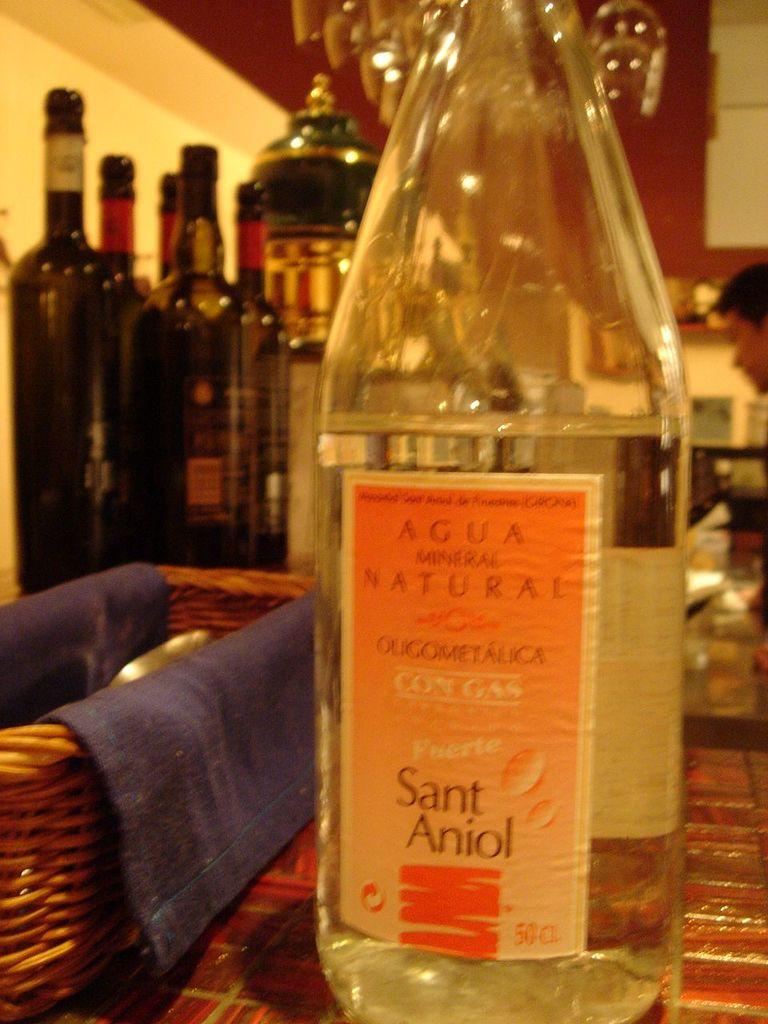What objects are present in the image? There are bottles and a spoon stand in the image. Can you describe the appearance of the bottles? One bottle is transparent, while the other bottles are in different colors. What is the purpose of the spoon stand? The spoon stand is used to hold spoons. What can be found inside the spoon stand? There is a blue cloth in the spoon stand. What type of fruit is being cooked by the hen in the image? There is no fruit, cooking, or hen present in the image. 